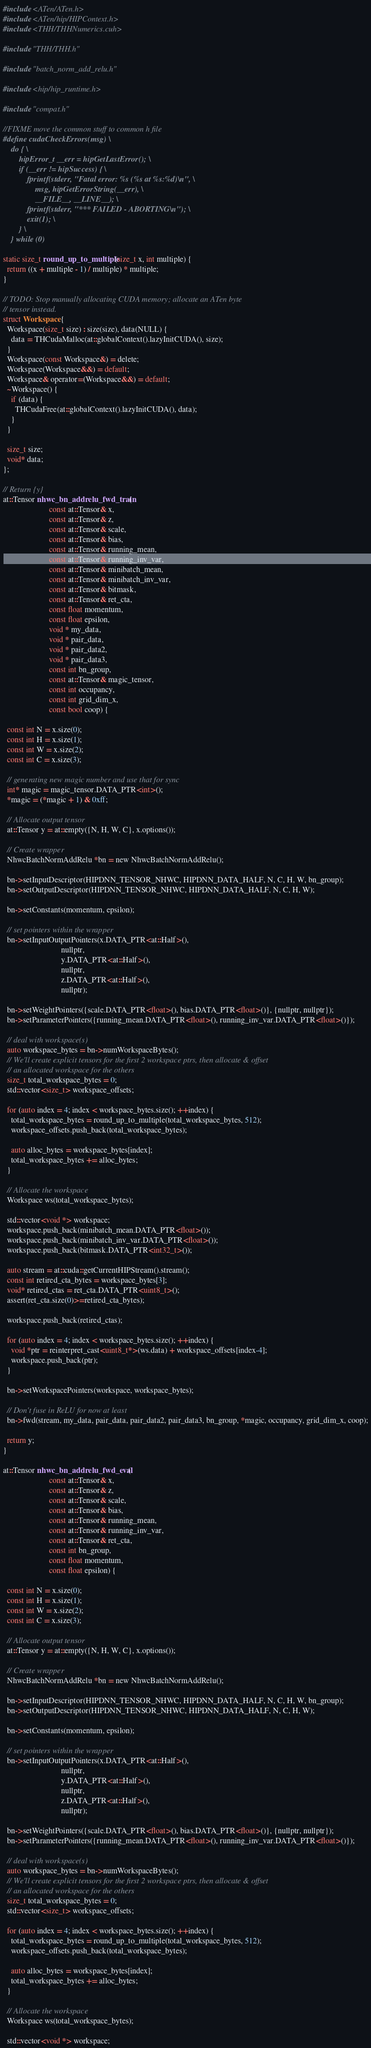Convert code to text. <code><loc_0><loc_0><loc_500><loc_500><_Cuda_>#include <ATen/ATen.h>
#include <ATen/hip/HIPContext.h>
#include <THH/THHNumerics.cuh>

#include "THH/THH.h"

#include "batch_norm_add_relu.h"

#include <hip/hip_runtime.h>

#include "compat.h"

//FIXME move the common stuff to common h file
#define cudaCheckErrors(msg) \
    do { \
        hipError_t __err = hipGetLastError(); \
        if (__err != hipSuccess) { \
            fprintf(stderr, "Fatal error: %s (%s at %s:%d)\n", \
                msg, hipGetErrorString(__err), \
                __FILE__, __LINE__); \
            fprintf(stderr, "*** FAILED - ABORTING\n"); \
            exit(1); \
        } \
    } while (0)

static size_t round_up_to_multiple(size_t x, int multiple) {
  return ((x + multiple - 1) / multiple) * multiple;
}

// TODO: Stop manually allocating CUDA memory; allocate an ATen byte
// tensor instead.
struct Workspace {
  Workspace(size_t size) : size(size), data(NULL) {
    data = THCudaMalloc(at::globalContext().lazyInitCUDA(), size);
  }
  Workspace(const Workspace&) = delete;
  Workspace(Workspace&&) = default;
  Workspace& operator=(Workspace&&) = default;
  ~Workspace() {
    if (data) {
      THCudaFree(at::globalContext().lazyInitCUDA(), data);
    }
  }

  size_t size;
  void* data;
};

// Return {y}
at::Tensor nhwc_bn_addrelu_fwd_train(
                       const at::Tensor& x,
                       const at::Tensor& z,
                       const at::Tensor& scale,
                       const at::Tensor& bias,
                       const at::Tensor& running_mean,
                       const at::Tensor& running_inv_var,
                       const at::Tensor& minibatch_mean,
                       const at::Tensor& minibatch_inv_var,
                       const at::Tensor& bitmask,
                       const at::Tensor& ret_cta,
                       const float momentum,
                       const float epsilon,
                       void * my_data,
                       void * pair_data,
                       void * pair_data2,
                       void * pair_data3,
                       const int bn_group,
                       const at::Tensor& magic_tensor,
                       const int occupancy,
                       const int grid_dim_x,
                       const bool coop) {

  const int N = x.size(0);
  const int H = x.size(1);
  const int W = x.size(2);
  const int C = x.size(3);

  // generating new magic number and use that for sync
  int* magic = magic_tensor.DATA_PTR<int>();
  *magic = (*magic + 1) & 0xff;

  // Allocate output tensor
  at::Tensor y = at::empty({N, H, W, C}, x.options());

  // Create wrapper
  NhwcBatchNormAddRelu *bn = new NhwcBatchNormAddRelu();

  bn->setInputDescriptor(HIPDNN_TENSOR_NHWC, HIPDNN_DATA_HALF, N, C, H, W, bn_group);
  bn->setOutputDescriptor(HIPDNN_TENSOR_NHWC, HIPDNN_DATA_HALF, N, C, H, W);

  bn->setConstants(momentum, epsilon);

  // set pointers within the wrapper
  bn->setInputOutputPointers(x.DATA_PTR<at::Half>(),
                             nullptr,
                             y.DATA_PTR<at::Half>(),
                             nullptr,
                             z.DATA_PTR<at::Half>(),
                             nullptr);

  bn->setWeightPointers({scale.DATA_PTR<float>(), bias.DATA_PTR<float>()}, {nullptr, nullptr});
  bn->setParameterPointers({running_mean.DATA_PTR<float>(), running_inv_var.DATA_PTR<float>()});

  // deal with workspace(s)
  auto workspace_bytes = bn->numWorkspaceBytes();
  // We'll create explicit tensors for the first 2 workspace ptrs, then allocate & offset
  // an allocated workspace for the others
  size_t total_workspace_bytes = 0;
  std::vector<size_t> workspace_offsets;

  for (auto index = 4; index < workspace_bytes.size(); ++index) {
    total_workspace_bytes = round_up_to_multiple(total_workspace_bytes, 512);
    workspace_offsets.push_back(total_workspace_bytes);

    auto alloc_bytes = workspace_bytes[index];
    total_workspace_bytes += alloc_bytes;
  }

  // Allocate the workspace
  Workspace ws(total_workspace_bytes);

  std::vector<void *> workspace;
  workspace.push_back(minibatch_mean.DATA_PTR<float>());
  workspace.push_back(minibatch_inv_var.DATA_PTR<float>());
  workspace.push_back(bitmask.DATA_PTR<int32_t>());

  auto stream = at::cuda::getCurrentHIPStream().stream();
  const int retired_cta_bytes = workspace_bytes[3];
  void* retired_ctas = ret_cta.DATA_PTR<uint8_t>();
  assert(ret_cta.size(0)>=retired_cta_bytes);

  workspace.push_back(retired_ctas);

  for (auto index = 4; index < workspace_bytes.size(); ++index) {
    void *ptr = reinterpret_cast<uint8_t*>(ws.data) + workspace_offsets[index-4];
    workspace.push_back(ptr);
  }

  bn->setWorkspacePointers(workspace, workspace_bytes);

  // Don't fuse in ReLU for now at least
  bn->fwd(stream, my_data, pair_data, pair_data2, pair_data3, bn_group, *magic, occupancy, grid_dim_x, coop);

  return y;
}

at::Tensor nhwc_bn_addrelu_fwd_eval(
                       const at::Tensor& x,
                       const at::Tensor& z,
                       const at::Tensor& scale,
                       const at::Tensor& bias,
                       const at::Tensor& running_mean,
                       const at::Tensor& running_inv_var,
                       const at::Tensor& ret_cta,
                       const int bn_group,
                       const float momentum,
                       const float epsilon) {

  const int N = x.size(0);
  const int H = x.size(1);
  const int W = x.size(2);
  const int C = x.size(3);

  // Allocate output tensor
  at::Tensor y = at::empty({N, H, W, C}, x.options());

  // Create wrapper
  NhwcBatchNormAddRelu *bn = new NhwcBatchNormAddRelu();

  bn->setInputDescriptor(HIPDNN_TENSOR_NHWC, HIPDNN_DATA_HALF, N, C, H, W, bn_group);
  bn->setOutputDescriptor(HIPDNN_TENSOR_NHWC, HIPDNN_DATA_HALF, N, C, H, W);

  bn->setConstants(momentum, epsilon);

  // set pointers within the wrapper
  bn->setInputOutputPointers(x.DATA_PTR<at::Half>(),
                             nullptr,
                             y.DATA_PTR<at::Half>(),
                             nullptr,
                             z.DATA_PTR<at::Half>(),
                             nullptr);

  bn->setWeightPointers({scale.DATA_PTR<float>(), bias.DATA_PTR<float>()}, {nullptr, nullptr});
  bn->setParameterPointers({running_mean.DATA_PTR<float>(), running_inv_var.DATA_PTR<float>()});

  // deal with workspace(s)
  auto workspace_bytes = bn->numWorkspaceBytes();
  // We'll create explicit tensors for the first 2 workspace ptrs, then allocate & offset
  // an allocated workspace for the others
  size_t total_workspace_bytes = 0;
  std::vector<size_t> workspace_offsets;

  for (auto index = 4; index < workspace_bytes.size(); ++index) {
    total_workspace_bytes = round_up_to_multiple(total_workspace_bytes, 512);
    workspace_offsets.push_back(total_workspace_bytes);

    auto alloc_bytes = workspace_bytes[index];
    total_workspace_bytes += alloc_bytes;
  }

  // Allocate the workspace
  Workspace ws(total_workspace_bytes);

  std::vector<void *> workspace;</code> 